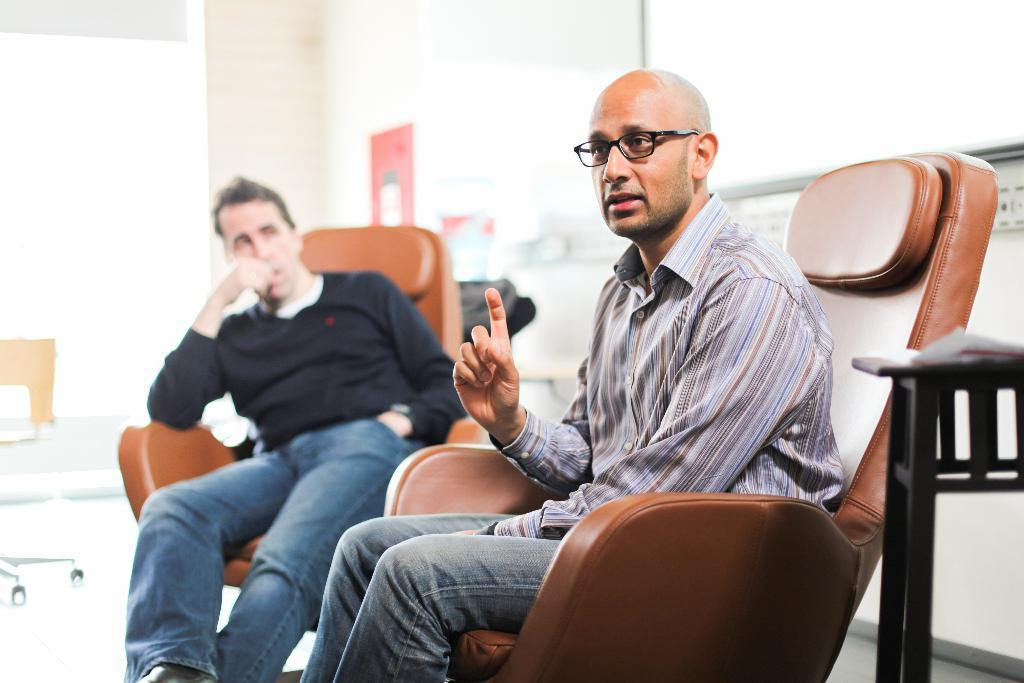How many people are in the image? There are two persons in the image. What are the persons doing in the image? The persons are sitting on chairs and talking. Can you describe one of the persons in the image? One person is wearing spectacles. What can be seen in the background of the image? There is a wall in the background of the image. What type of plant is providing advice to the persons in the image? There is no plant present in the image, and therefore no such interaction can be observed. 